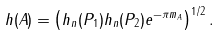Convert formula to latex. <formula><loc_0><loc_0><loc_500><loc_500>h ( A ) = \left ( h _ { n } ( P _ { 1 } ) h _ { n } ( P _ { 2 } ) e ^ { - \pi m _ { A } } \right ) ^ { 1 / 2 } .</formula> 